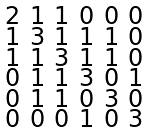Convert formula to latex. <formula><loc_0><loc_0><loc_500><loc_500>\begin{smallmatrix} 2 & 1 & 1 & 0 & 0 & 0 \\ 1 & 3 & 1 & 1 & 1 & 0 \\ 1 & 1 & 3 & 1 & 1 & 0 \\ 0 & 1 & 1 & 3 & 0 & 1 \\ 0 & 1 & 1 & 0 & 3 & 0 \\ 0 & 0 & 0 & 1 & 0 & 3 \end{smallmatrix}</formula> 